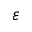<formula> <loc_0><loc_0><loc_500><loc_500>{ \varepsilon }</formula> 